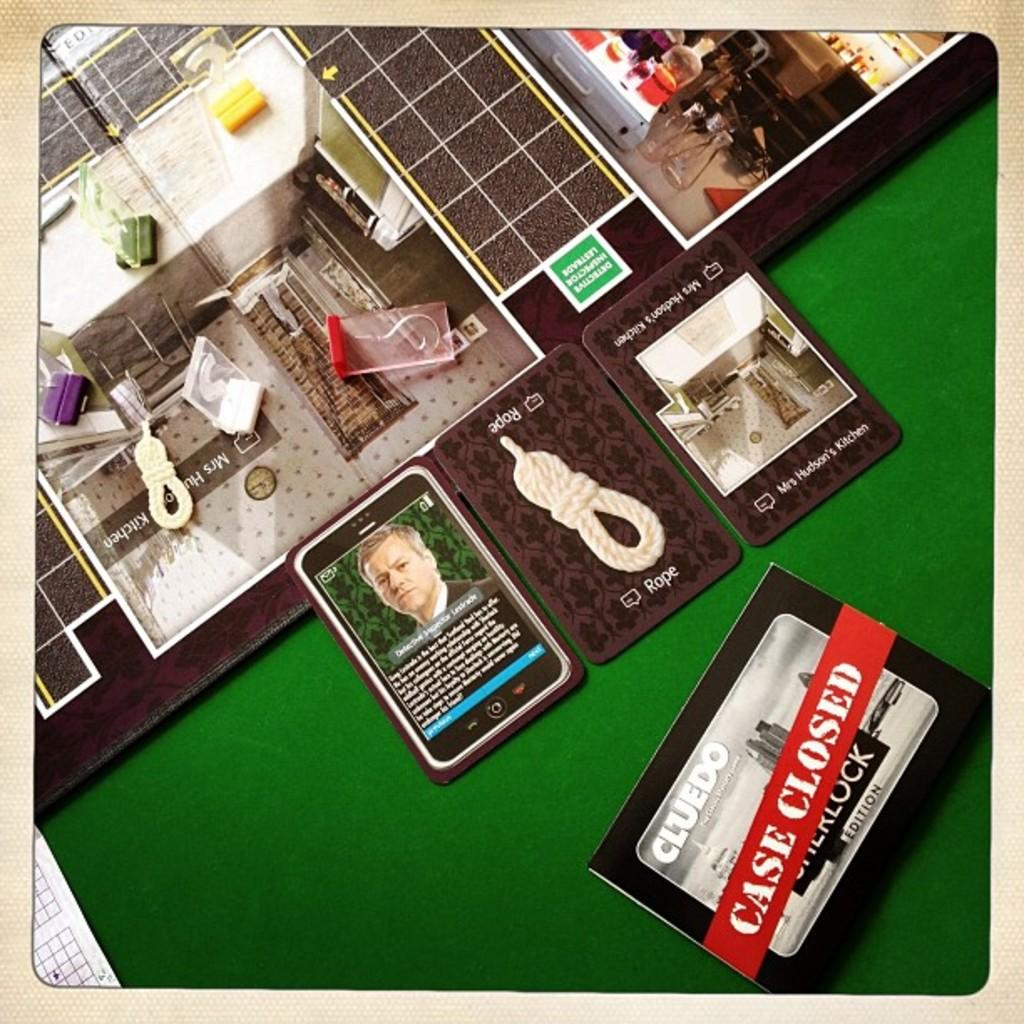<image>
Render a clear and concise summary of the photo. A board game called cluedo is laid out on the green table top with all the pieces arranged into places. 